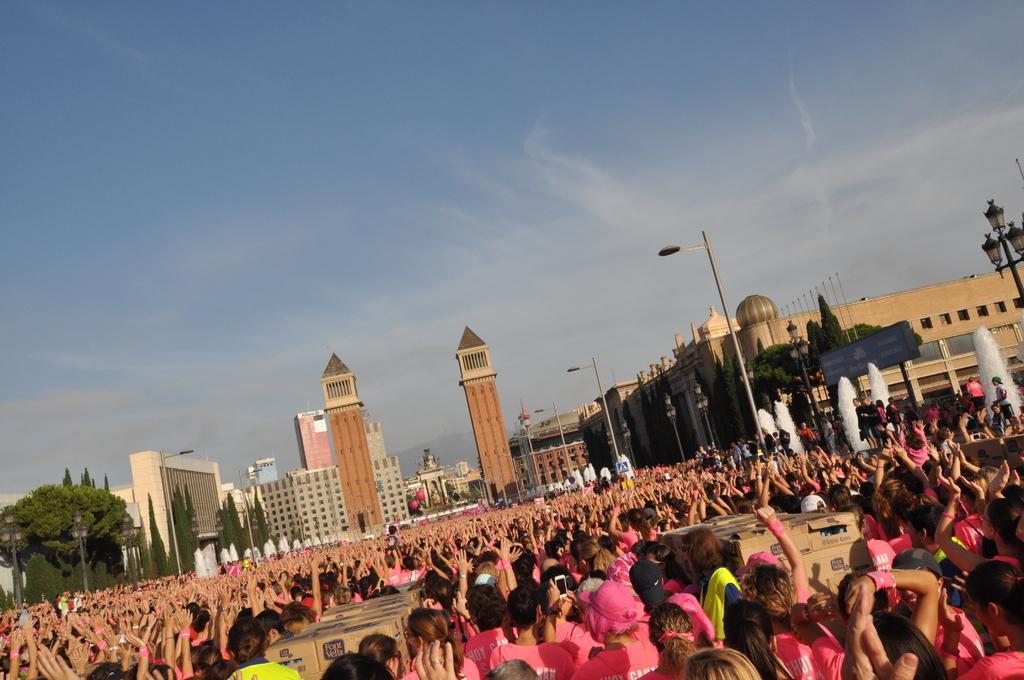Please provide a concise description of this image. In this image we can see a group of people are standing, they are wearing the pink color dress, here is the building, here is the tree, here is the tower, here is the street light, at above here is the sky. 